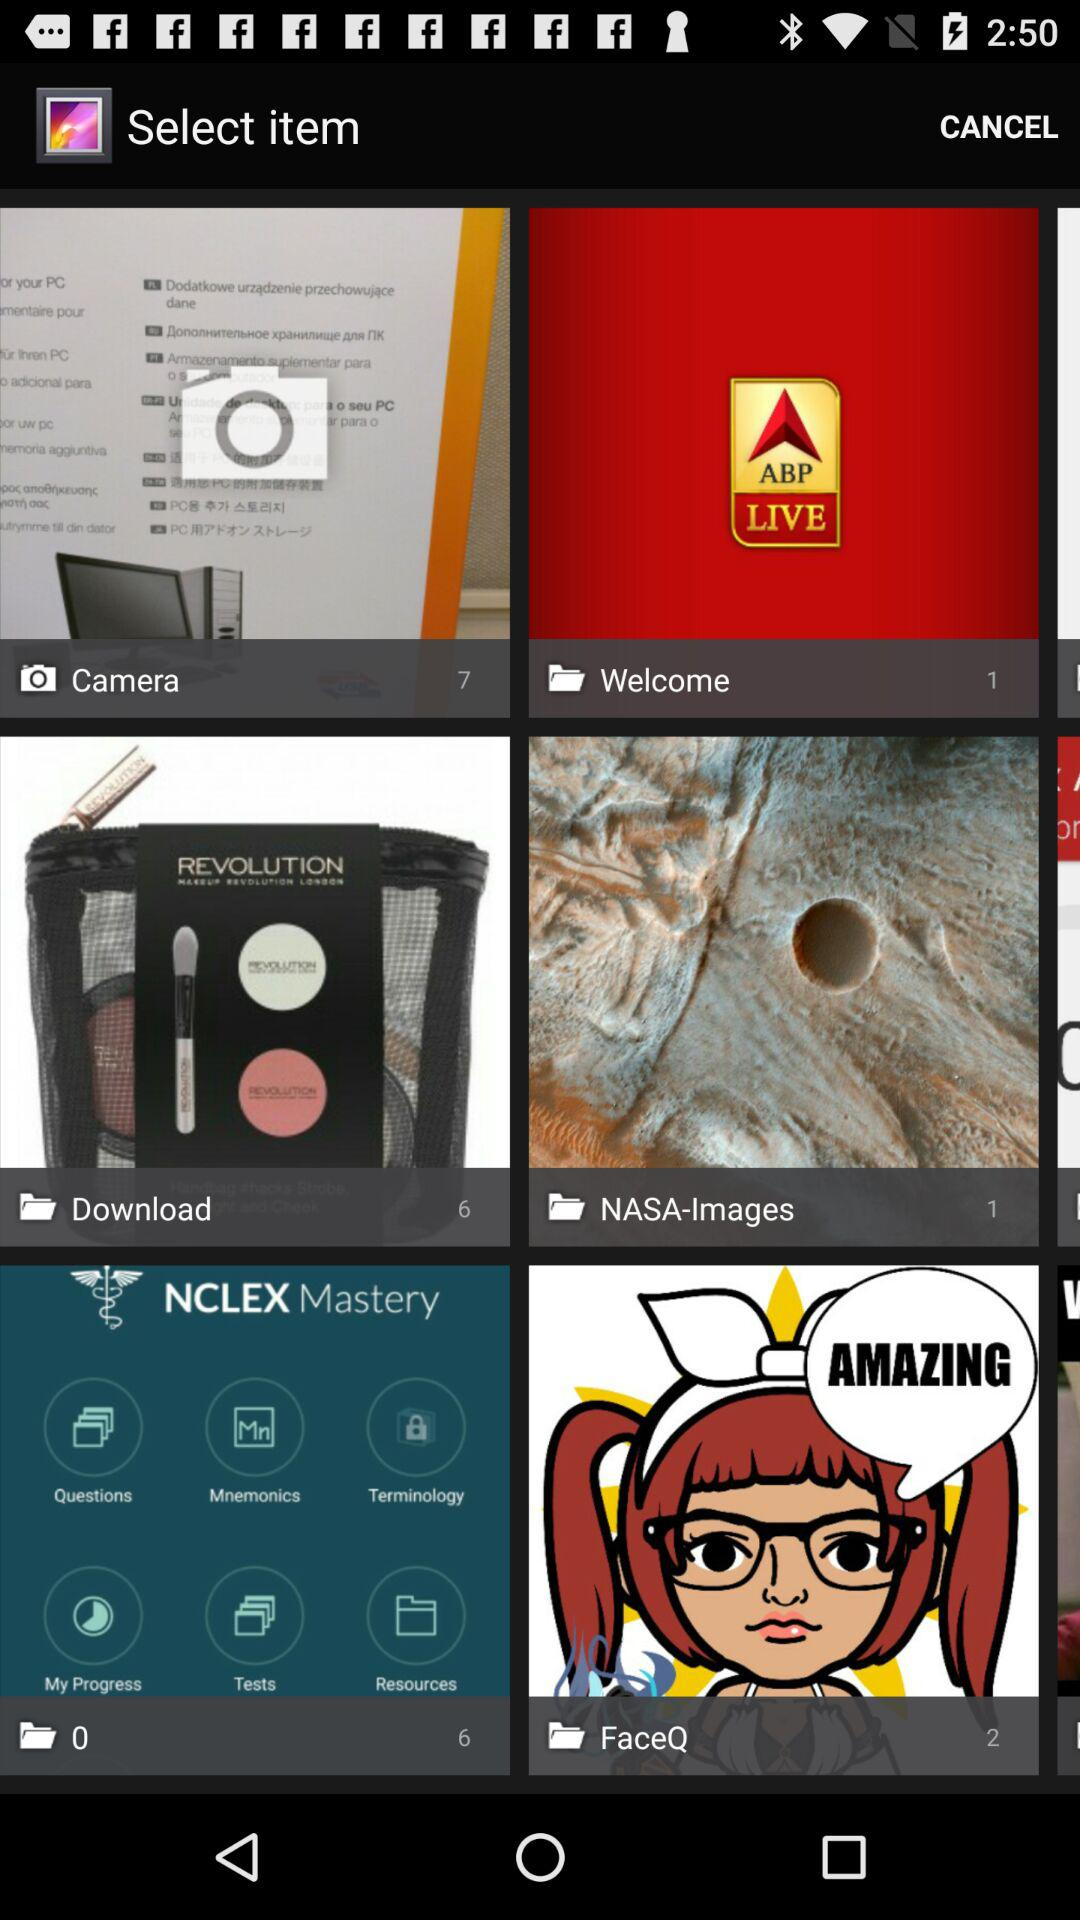Which folder has 2 items? The folder that has 2 items is "FaceQ". 